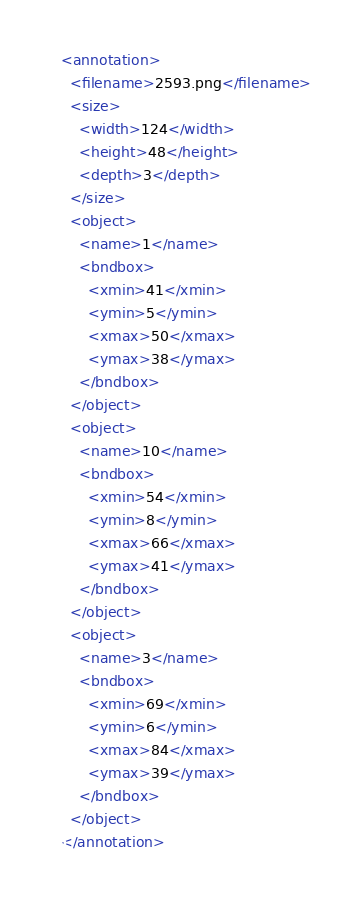Convert code to text. <code><loc_0><loc_0><loc_500><loc_500><_XML_><annotation>
  <filename>2593.png</filename>
  <size>
    <width>124</width>
    <height>48</height>
    <depth>3</depth>
  </size>
  <object>
    <name>1</name>
    <bndbox>
      <xmin>41</xmin>
      <ymin>5</ymin>
      <xmax>50</xmax>
      <ymax>38</ymax>
    </bndbox>
  </object>
  <object>
    <name>10</name>
    <bndbox>
      <xmin>54</xmin>
      <ymin>8</ymin>
      <xmax>66</xmax>
      <ymax>41</ymax>
    </bndbox>
  </object>
  <object>
    <name>3</name>
    <bndbox>
      <xmin>69</xmin>
      <ymin>6</ymin>
      <xmax>84</xmax>
      <ymax>39</ymax>
    </bndbox>
  </object>
</annotation>
</code> 